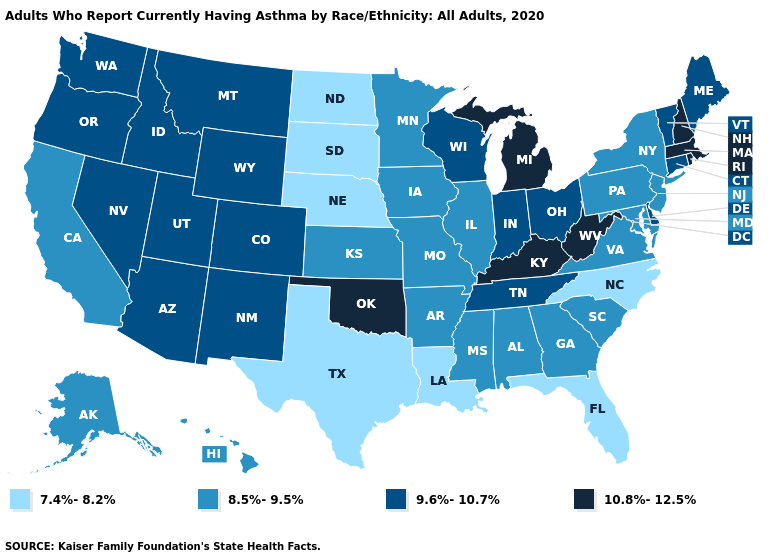What is the highest value in states that border California?
Concise answer only. 9.6%-10.7%. Among the states that border Wyoming , does Colorado have the highest value?
Concise answer only. Yes. Does Nebraska have the lowest value in the MidWest?
Give a very brief answer. Yes. What is the highest value in states that border Colorado?
Give a very brief answer. 10.8%-12.5%. Name the states that have a value in the range 10.8%-12.5%?
Write a very short answer. Kentucky, Massachusetts, Michigan, New Hampshire, Oklahoma, Rhode Island, West Virginia. Name the states that have a value in the range 7.4%-8.2%?
Keep it brief. Florida, Louisiana, Nebraska, North Carolina, North Dakota, South Dakota, Texas. Does Mississippi have a lower value than Oregon?
Give a very brief answer. Yes. Among the states that border Ohio , does Kentucky have the highest value?
Be succinct. Yes. Does the map have missing data?
Keep it brief. No. Among the states that border New Jersey , which have the lowest value?
Concise answer only. New York, Pennsylvania. Among the states that border Kentucky , which have the lowest value?
Be succinct. Illinois, Missouri, Virginia. What is the lowest value in states that border Arizona?
Give a very brief answer. 8.5%-9.5%. Name the states that have a value in the range 8.5%-9.5%?
Give a very brief answer. Alabama, Alaska, Arkansas, California, Georgia, Hawaii, Illinois, Iowa, Kansas, Maryland, Minnesota, Mississippi, Missouri, New Jersey, New York, Pennsylvania, South Carolina, Virginia. Name the states that have a value in the range 10.8%-12.5%?
Give a very brief answer. Kentucky, Massachusetts, Michigan, New Hampshire, Oklahoma, Rhode Island, West Virginia. Does Louisiana have the lowest value in the USA?
Quick response, please. Yes. 